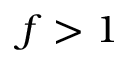Convert formula to latex. <formula><loc_0><loc_0><loc_500><loc_500>f > 1</formula> 